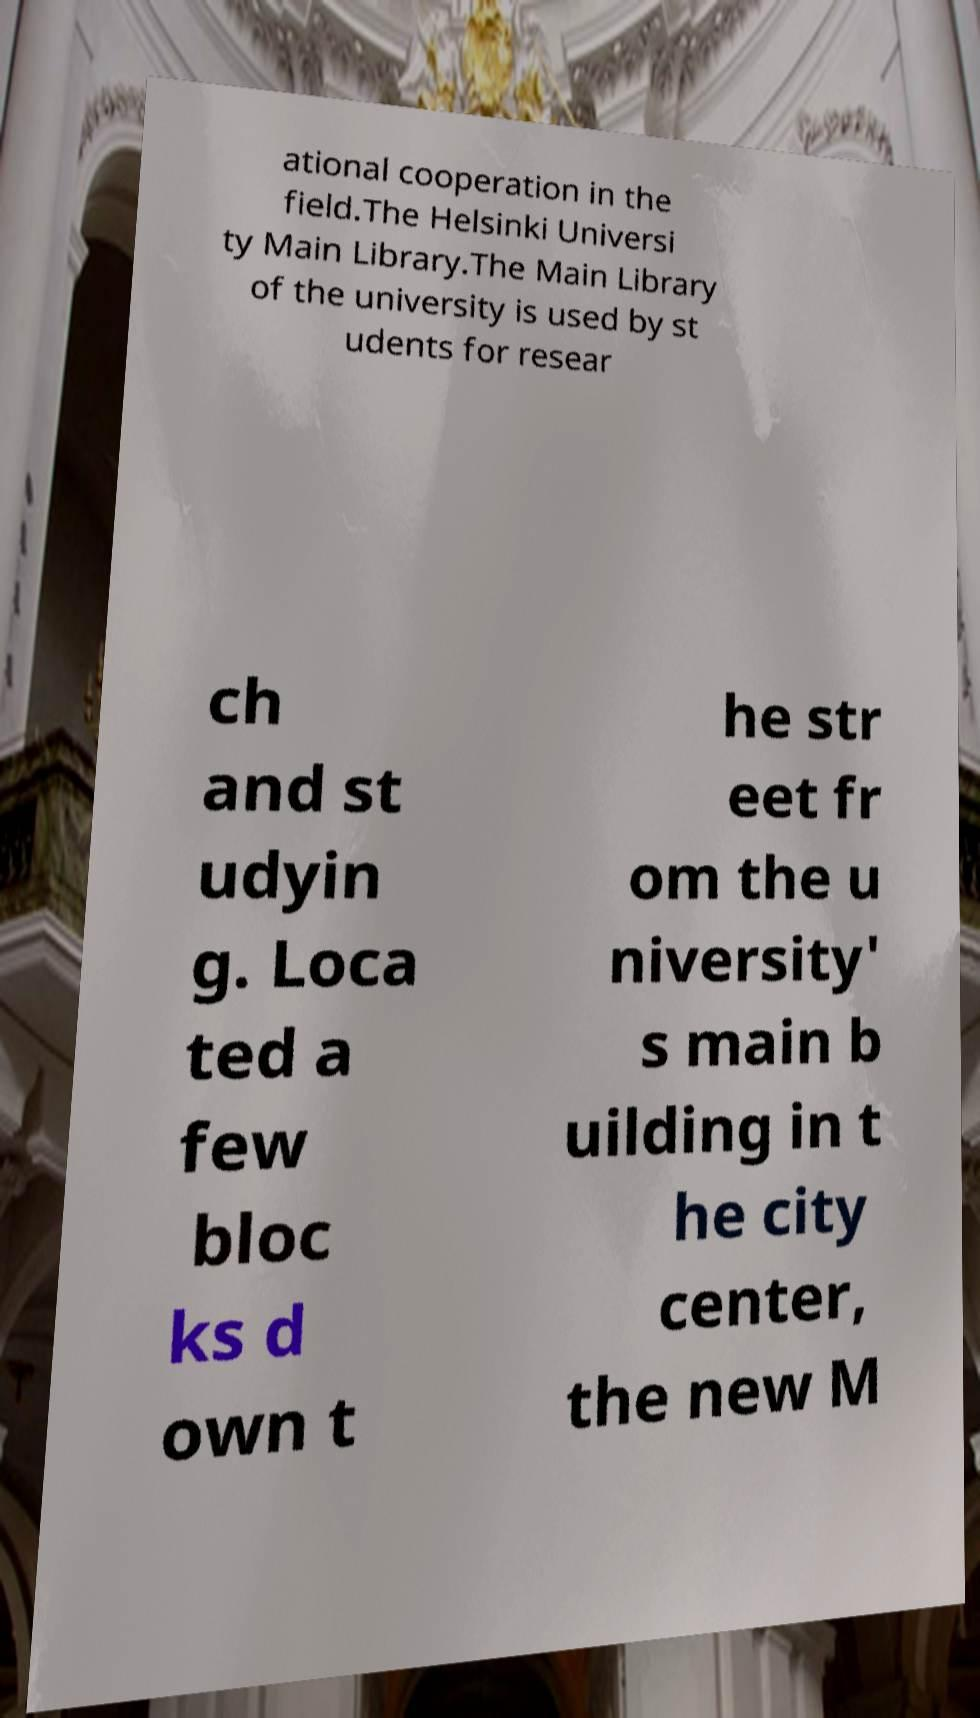Can you read and provide the text displayed in the image?This photo seems to have some interesting text. Can you extract and type it out for me? ational cooperation in the field.The Helsinki Universi ty Main Library.The Main Library of the university is used by st udents for resear ch and st udyin g. Loca ted a few bloc ks d own t he str eet fr om the u niversity' s main b uilding in t he city center, the new M 